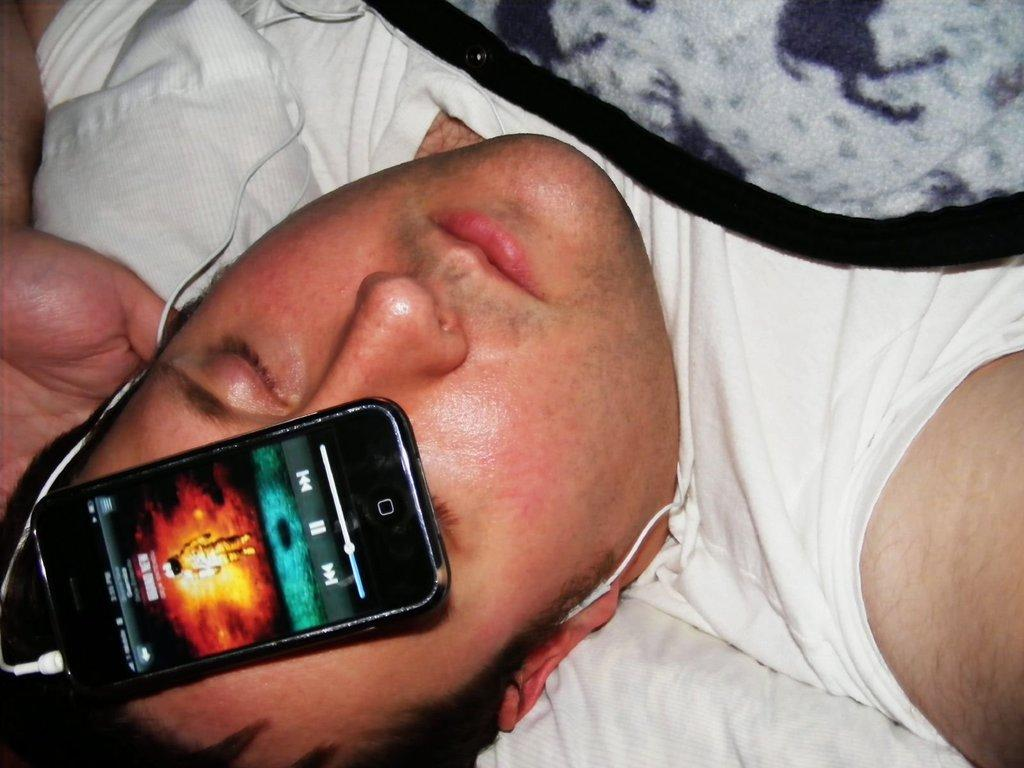Who is present in the image? There is a man in the image. What is the man wearing? The man is wearing a white dress. What is the man doing in the image? The man is sleeping on the bed. What is placed on the man's face? There is a mobile placed on the man's face. What is the man measuring in the image? There is no indication in the image that the man is measuring anything. 